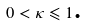<formula> <loc_0><loc_0><loc_500><loc_500>\text {\ } 0 < \kappa \leqslant 1 \text {.}</formula> 